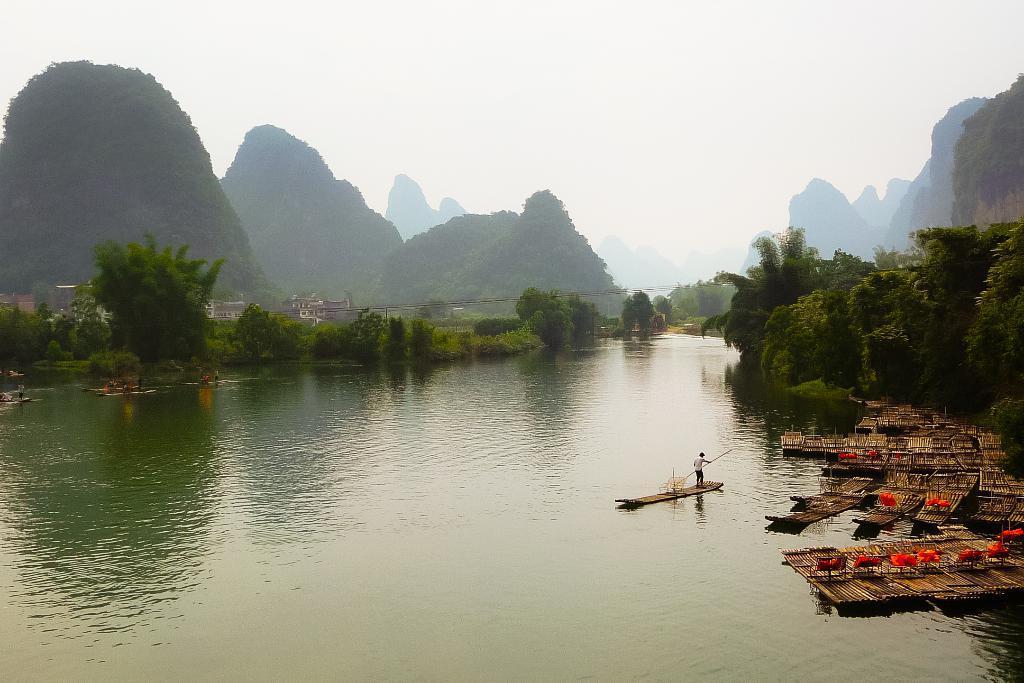Describe this image in one or two sentences. In the center of the image there is water. There are boats. To the both sides of the image there are trees. In the background of the image there are mountains, houses, sky. 